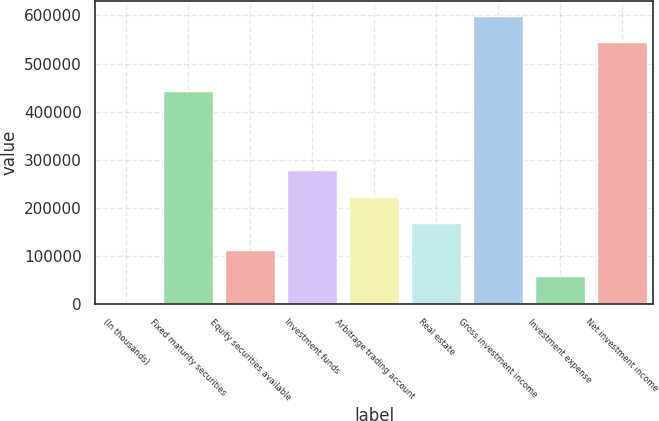Convert chart. <chart><loc_0><loc_0><loc_500><loc_500><bar_chart><fcel>(In thousands)<fcel>Fixed maturity securities<fcel>Equity securities available<fcel>Investment funds<fcel>Arbitrage trading account<fcel>Real estate<fcel>Gross investment income<fcel>Investment expense<fcel>Net investment income<nl><fcel>2013<fcel>442287<fcel>112472<fcel>278160<fcel>222931<fcel>167702<fcel>599520<fcel>57242.5<fcel>544291<nl></chart> 